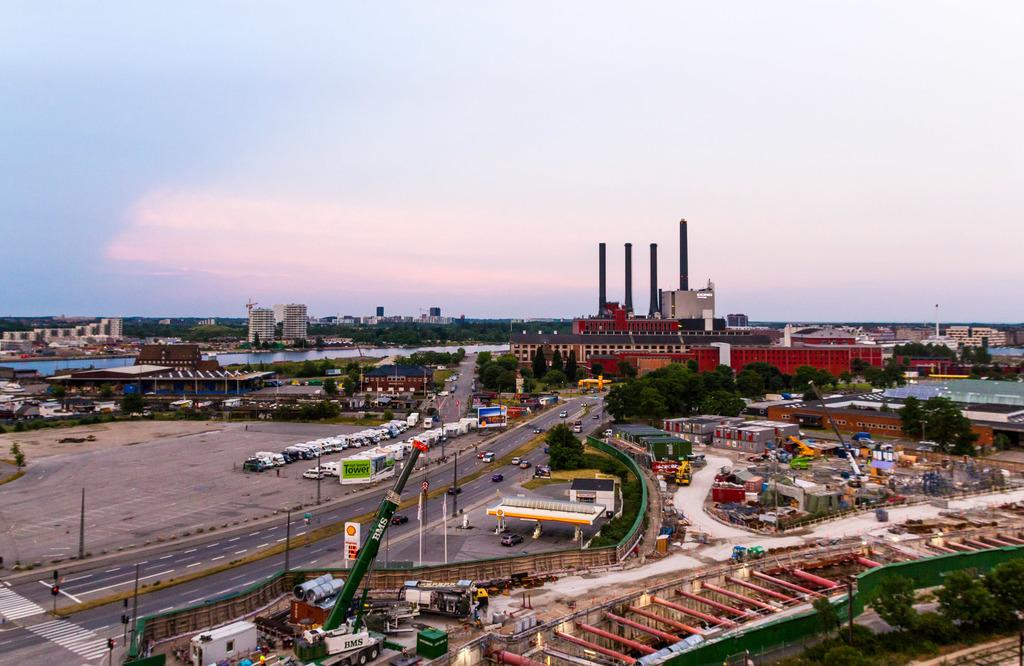What types of man-made structures can be seen in the image? There are buildings in the image. What types of transportation are visible in the image? There are vehicles in the image. What type of natural vegetation is present in the image? There are trees in the image. What type of surface can be seen in the image that allows for movement? There are roads in the image. What other objects can be seen in the image besides vehicles, buildings, trees, and roads? There are other objects in the image. What is visible at the top of the image? The sky is visible at the top of the image. What type of arithmetic problem can be solved using the coal in the image? There is no coal present in the image, so it is not possible to solve an arithmetic problem using it. What type of jelly can be seen on the buildings in the image? There is no jelly present on the buildings in the image. 